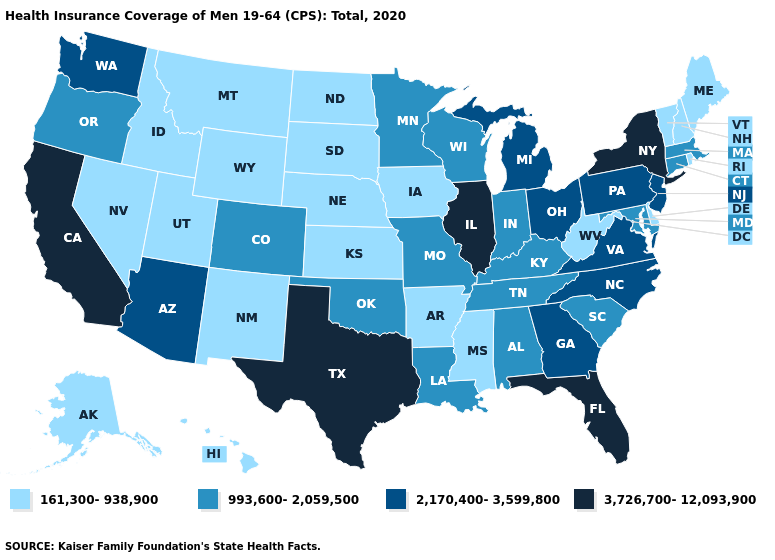Name the states that have a value in the range 993,600-2,059,500?
Quick response, please. Alabama, Colorado, Connecticut, Indiana, Kentucky, Louisiana, Maryland, Massachusetts, Minnesota, Missouri, Oklahoma, Oregon, South Carolina, Tennessee, Wisconsin. What is the value of Florida?
Be succinct. 3,726,700-12,093,900. What is the value of Connecticut?
Short answer required. 993,600-2,059,500. Does California have the lowest value in the USA?
Keep it brief. No. What is the value of Iowa?
Be succinct. 161,300-938,900. Name the states that have a value in the range 993,600-2,059,500?
Concise answer only. Alabama, Colorado, Connecticut, Indiana, Kentucky, Louisiana, Maryland, Massachusetts, Minnesota, Missouri, Oklahoma, Oregon, South Carolina, Tennessee, Wisconsin. Which states have the lowest value in the Northeast?
Write a very short answer. Maine, New Hampshire, Rhode Island, Vermont. Does Nevada have the lowest value in the West?
Answer briefly. Yes. Does Virginia have the highest value in the USA?
Keep it brief. No. Which states have the lowest value in the USA?
Quick response, please. Alaska, Arkansas, Delaware, Hawaii, Idaho, Iowa, Kansas, Maine, Mississippi, Montana, Nebraska, Nevada, New Hampshire, New Mexico, North Dakota, Rhode Island, South Dakota, Utah, Vermont, West Virginia, Wyoming. What is the value of California?
Concise answer only. 3,726,700-12,093,900. What is the lowest value in the USA?
Write a very short answer. 161,300-938,900. Name the states that have a value in the range 2,170,400-3,599,800?
Keep it brief. Arizona, Georgia, Michigan, New Jersey, North Carolina, Ohio, Pennsylvania, Virginia, Washington. What is the highest value in the West ?
Be succinct. 3,726,700-12,093,900. Name the states that have a value in the range 3,726,700-12,093,900?
Short answer required. California, Florida, Illinois, New York, Texas. 